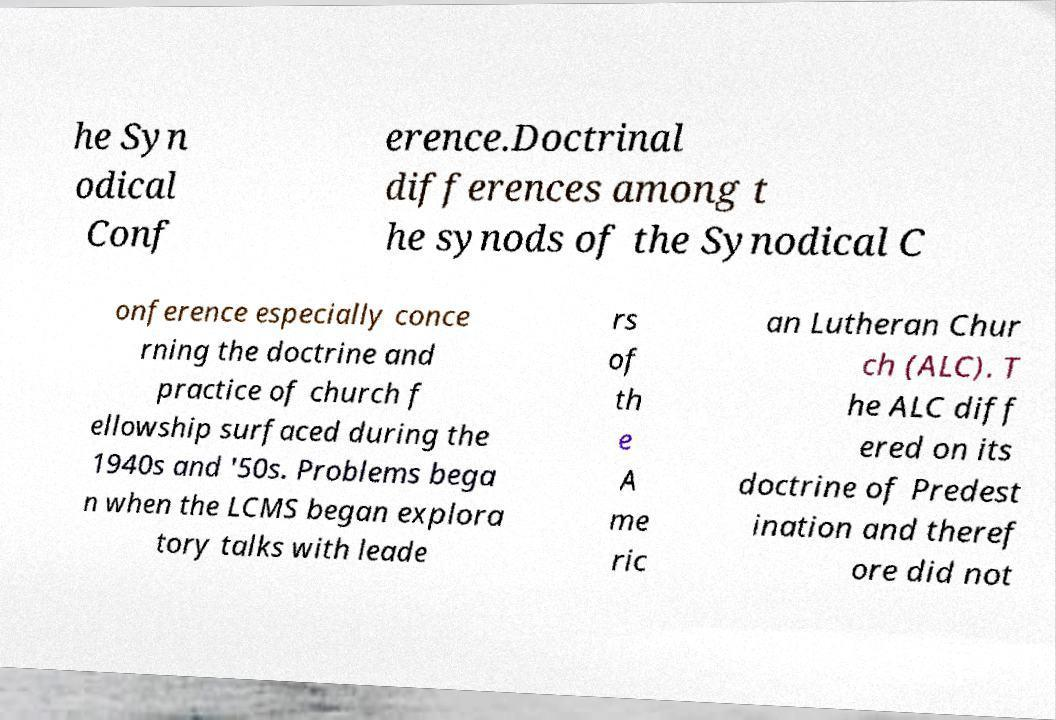Could you assist in decoding the text presented in this image and type it out clearly? he Syn odical Conf erence.Doctrinal differences among t he synods of the Synodical C onference especially conce rning the doctrine and practice of church f ellowship surfaced during the 1940s and '50s. Problems bega n when the LCMS began explora tory talks with leade rs of th e A me ric an Lutheran Chur ch (ALC). T he ALC diff ered on its doctrine of Predest ination and theref ore did not 